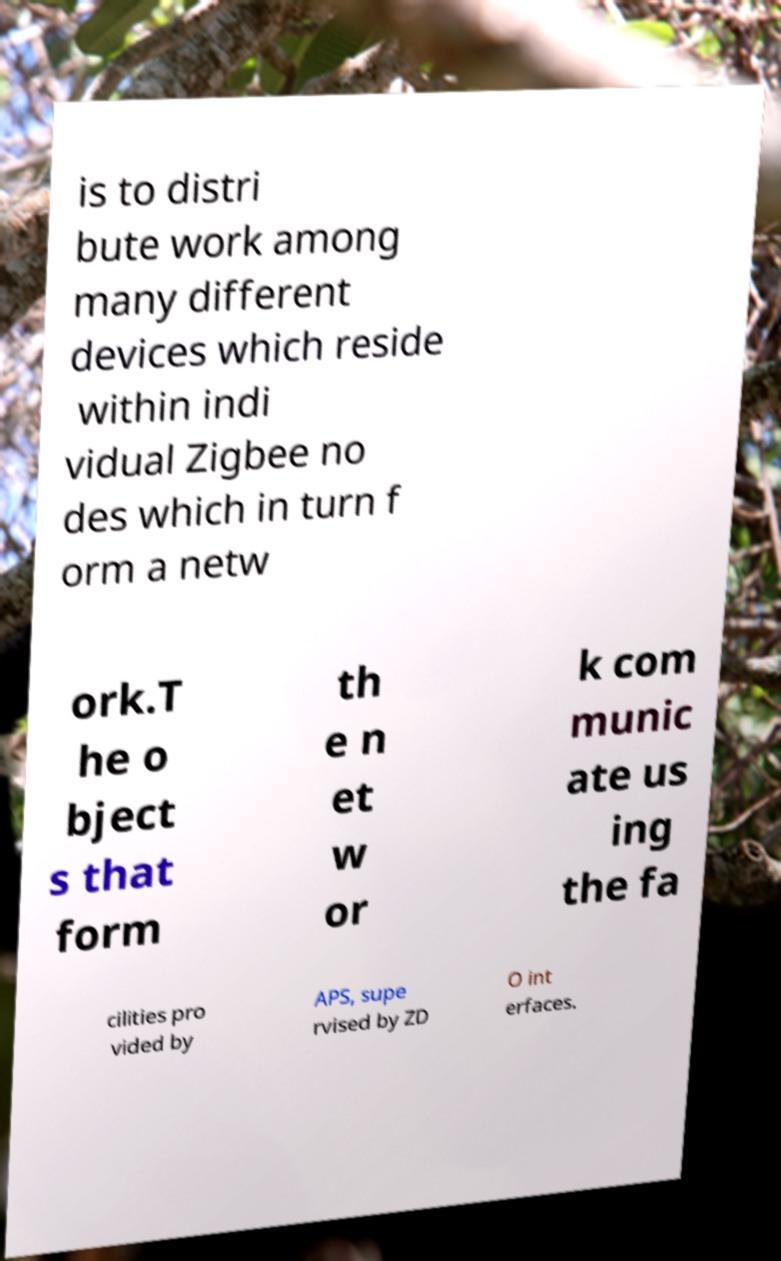For documentation purposes, I need the text within this image transcribed. Could you provide that? is to distri bute work among many different devices which reside within indi vidual Zigbee no des which in turn f orm a netw ork.T he o bject s that form th e n et w or k com munic ate us ing the fa cilities pro vided by APS, supe rvised by ZD O int erfaces. 